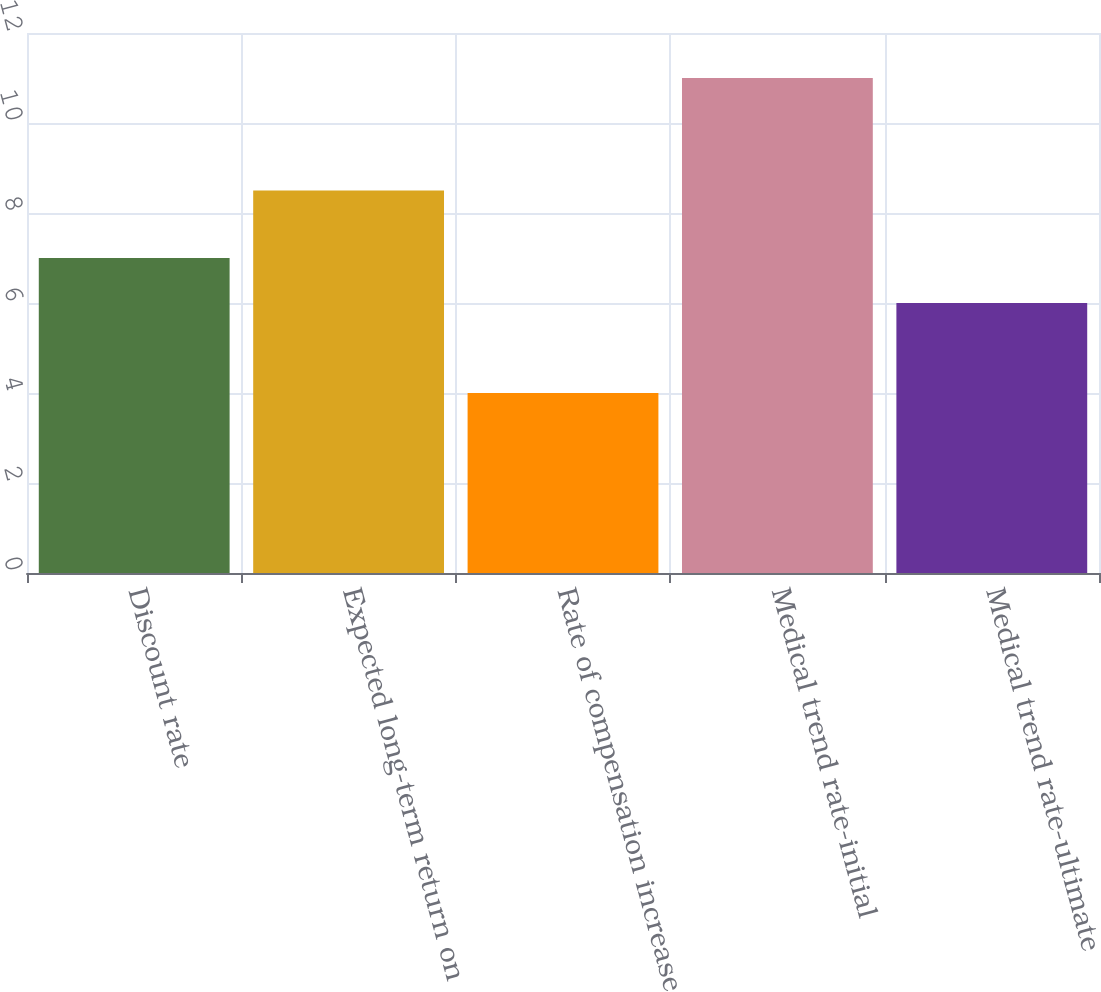Convert chart. <chart><loc_0><loc_0><loc_500><loc_500><bar_chart><fcel>Discount rate<fcel>Expected long-term return on<fcel>Rate of compensation increase<fcel>Medical trend rate-initial<fcel>Medical trend rate-ultimate<nl><fcel>7<fcel>8.5<fcel>4<fcel>11<fcel>6<nl></chart> 